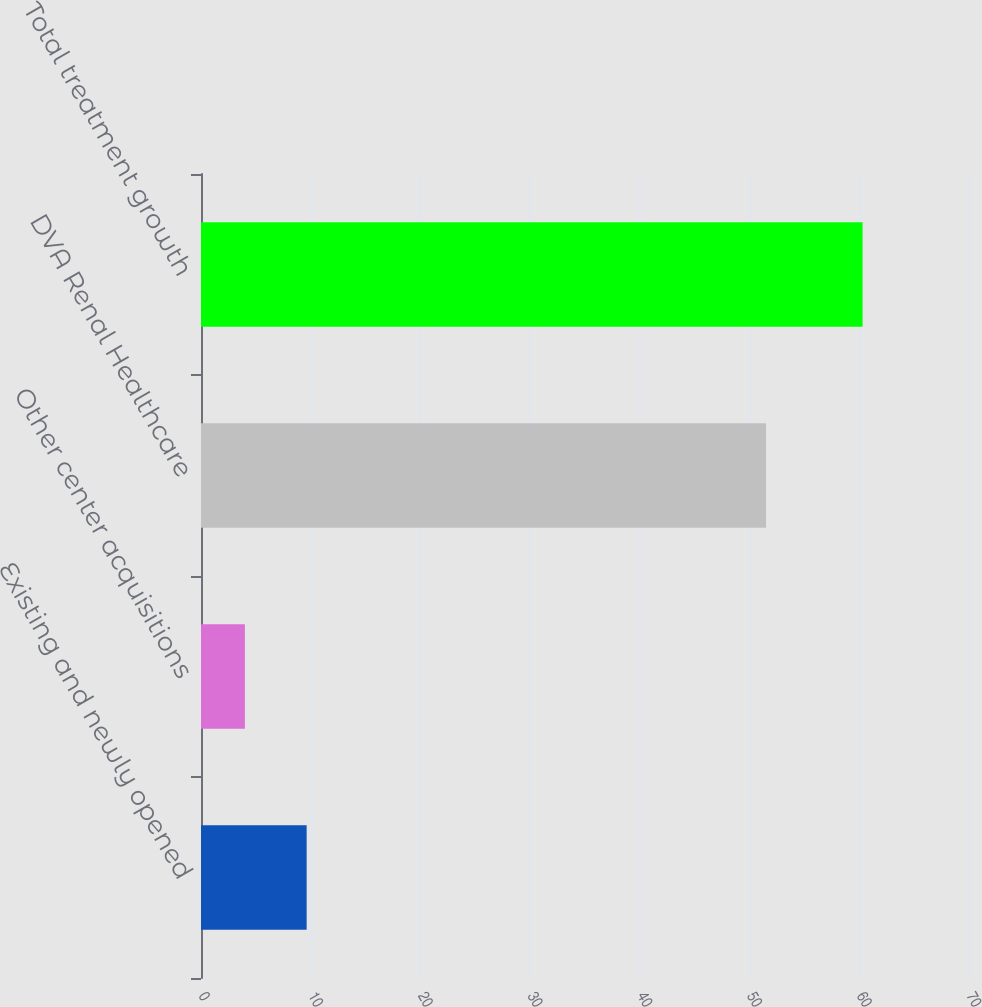<chart> <loc_0><loc_0><loc_500><loc_500><bar_chart><fcel>Existing and newly opened<fcel>Other center acquisitions<fcel>DVA Renal Healthcare<fcel>Total treatment growth<nl><fcel>9.63<fcel>4<fcel>51.5<fcel>60.3<nl></chart> 